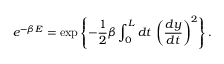Convert formula to latex. <formula><loc_0><loc_0><loc_500><loc_500>e ^ { - \beta E } = \exp \left \{ - \frac { 1 } { 2 } \beta \int _ { 0 } ^ { L } d t \, \left ( \frac { d y } { d t } \right ) ^ { 2 } \right \} .</formula> 